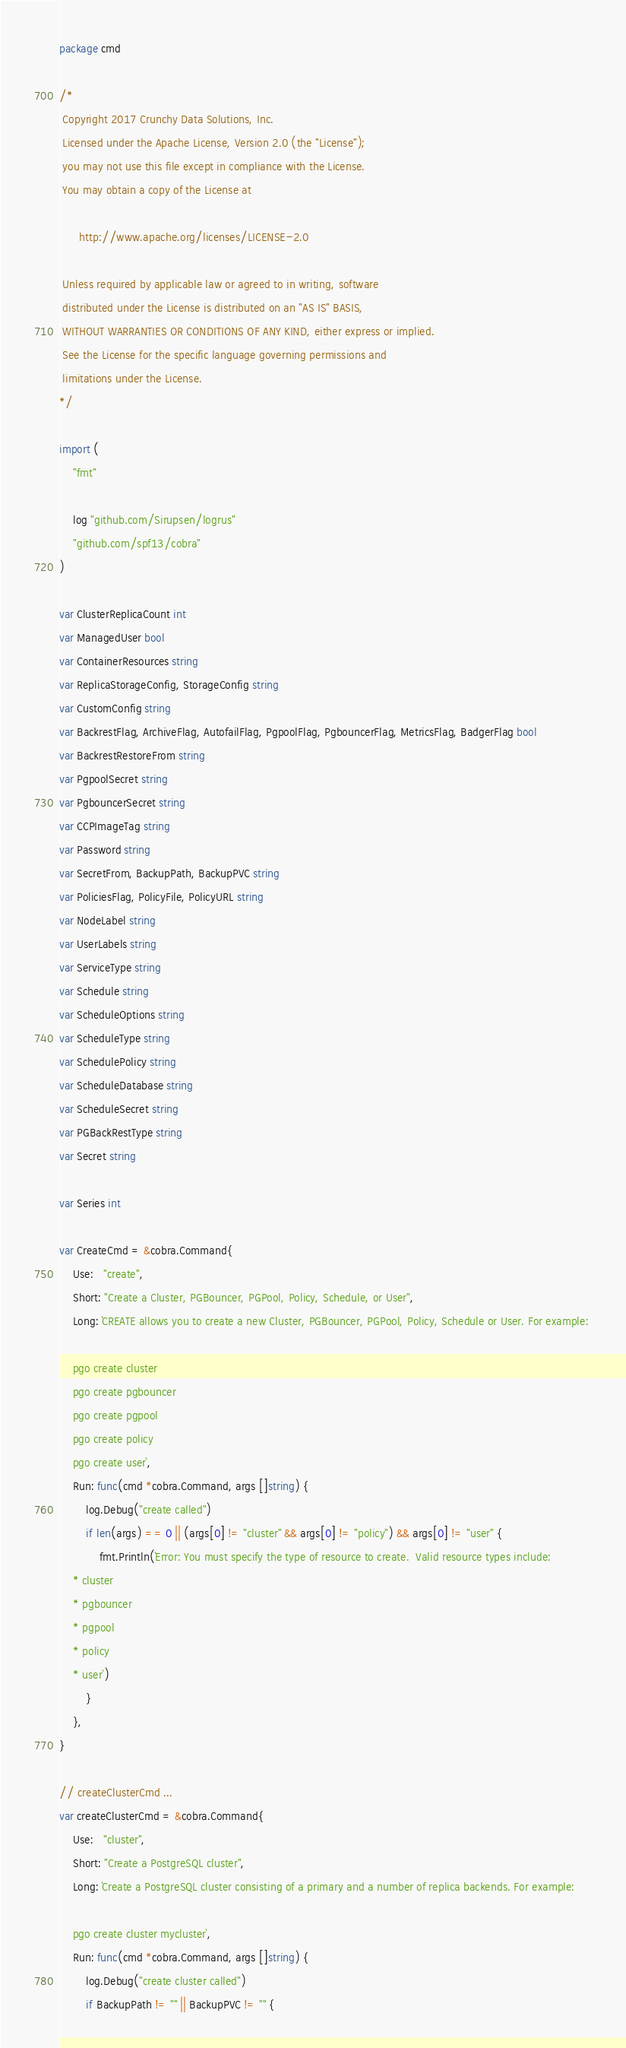Convert code to text. <code><loc_0><loc_0><loc_500><loc_500><_Go_>package cmd

/*
 Copyright 2017 Crunchy Data Solutions, Inc.
 Licensed under the Apache License, Version 2.0 (the "License");
 you may not use this file except in compliance with the License.
 You may obtain a copy of the License at

      http://www.apache.org/licenses/LICENSE-2.0

 Unless required by applicable law or agreed to in writing, software
 distributed under the License is distributed on an "AS IS" BASIS,
 WITHOUT WARRANTIES OR CONDITIONS OF ANY KIND, either express or implied.
 See the License for the specific language governing permissions and
 limitations under the License.
*/

import (
	"fmt"

	log "github.com/Sirupsen/logrus"
	"github.com/spf13/cobra"
)

var ClusterReplicaCount int
var ManagedUser bool
var ContainerResources string
var ReplicaStorageConfig, StorageConfig string
var CustomConfig string
var BackrestFlag, ArchiveFlag, AutofailFlag, PgpoolFlag, PgbouncerFlag, MetricsFlag, BadgerFlag bool
var BackrestRestoreFrom string
var PgpoolSecret string
var PgbouncerSecret string
var CCPImageTag string
var Password string
var SecretFrom, BackupPath, BackupPVC string
var PoliciesFlag, PolicyFile, PolicyURL string
var NodeLabel string
var UserLabels string
var ServiceType string
var Schedule string
var ScheduleOptions string
var ScheduleType string
var SchedulePolicy string
var ScheduleDatabase string
var ScheduleSecret string
var PGBackRestType string
var Secret string

var Series int

var CreateCmd = &cobra.Command{
	Use:   "create",
	Short: "Create a Cluster, PGBouncer, PGPool, Policy, Schedule, or User",
	Long: `CREATE allows you to create a new Cluster, PGBouncer, PGPool, Policy, Schedule or User. For example: 

    pgo create cluster
    pgo create pgbouncer
    pgo create pgpool
    pgo create policy
    pgo create user`,
	Run: func(cmd *cobra.Command, args []string) {
		log.Debug("create called")
		if len(args) == 0 || (args[0] != "cluster" && args[0] != "policy") && args[0] != "user" {
			fmt.Println(`Error: You must specify the type of resource to create.  Valid resource types include:
    * cluster
    * pgbouncer
    * pgpool
    * policy
    * user`)
		}
	},
}

// createClusterCmd ...
var createClusterCmd = &cobra.Command{
	Use:   "cluster",
	Short: "Create a PostgreSQL cluster",
	Long: `Create a PostgreSQL cluster consisting of a primary and a number of replica backends. For example:

    pgo create cluster mycluster`,
	Run: func(cmd *cobra.Command, args []string) {
		log.Debug("create cluster called")
		if BackupPath != "" || BackupPVC != "" {</code> 